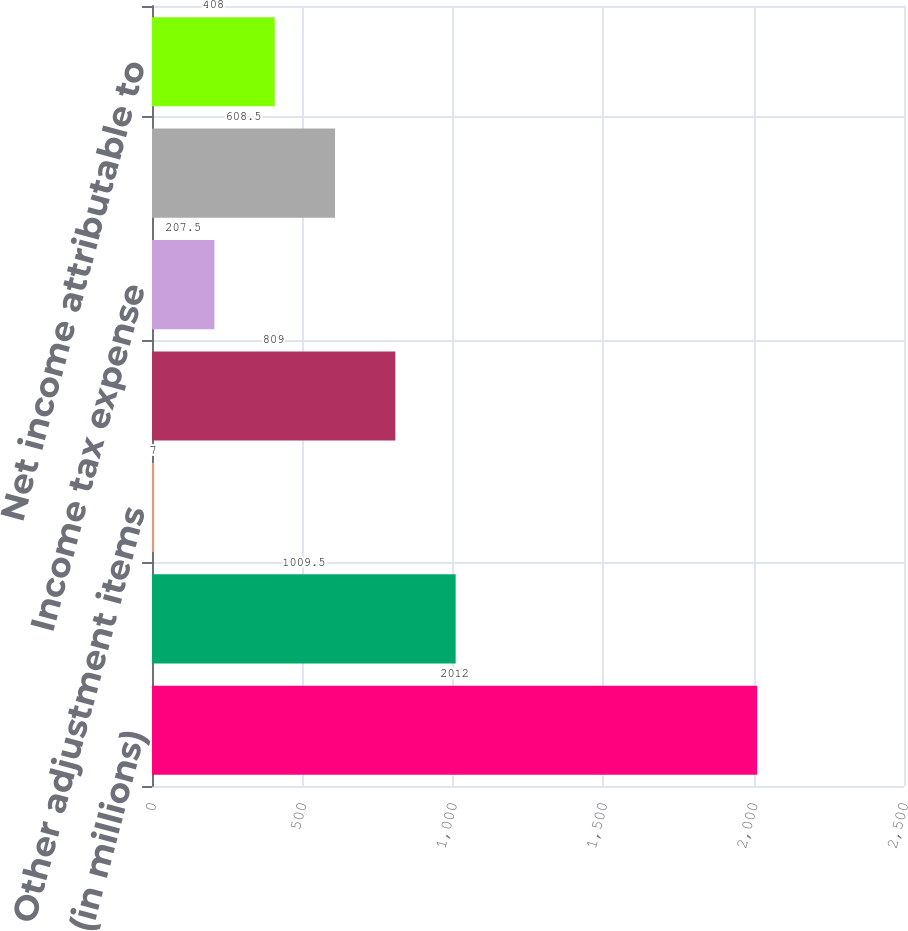Convert chart to OTSL. <chart><loc_0><loc_0><loc_500><loc_500><bar_chart><fcel>(in millions)<fcel>Adjusted EBITDA<fcel>Other adjustment items<fcel>EBITDA<fcel>Income tax expense<fcel>Depreciation and amortization<fcel>Net income attributable to<nl><fcel>2012<fcel>1009.5<fcel>7<fcel>809<fcel>207.5<fcel>608.5<fcel>408<nl></chart> 